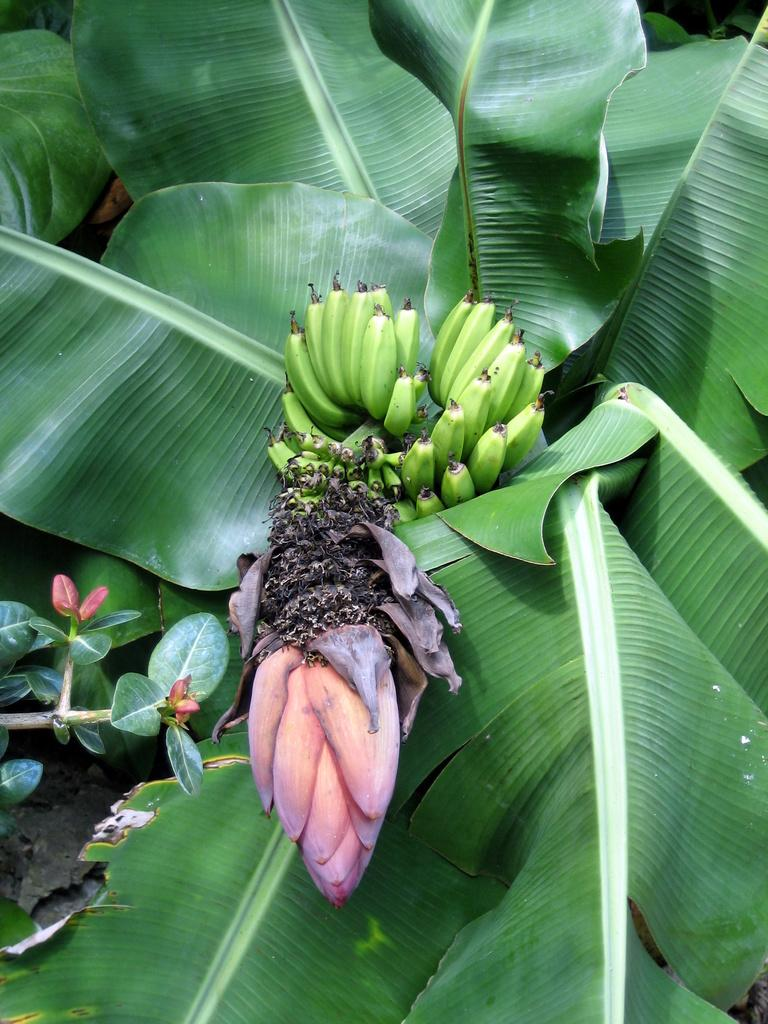What type of tree is present in the image? There is a banana tree in the image. What can be seen on the banana tree? There are bananas visible on the tree, as well as leaves. Are there any other branches or trees visible in the image? Yes, there is another tree branch on the left side of the image. What texture can be felt on the cats in the image? There are no cats present in the image, so it is not possible to determine their texture. 